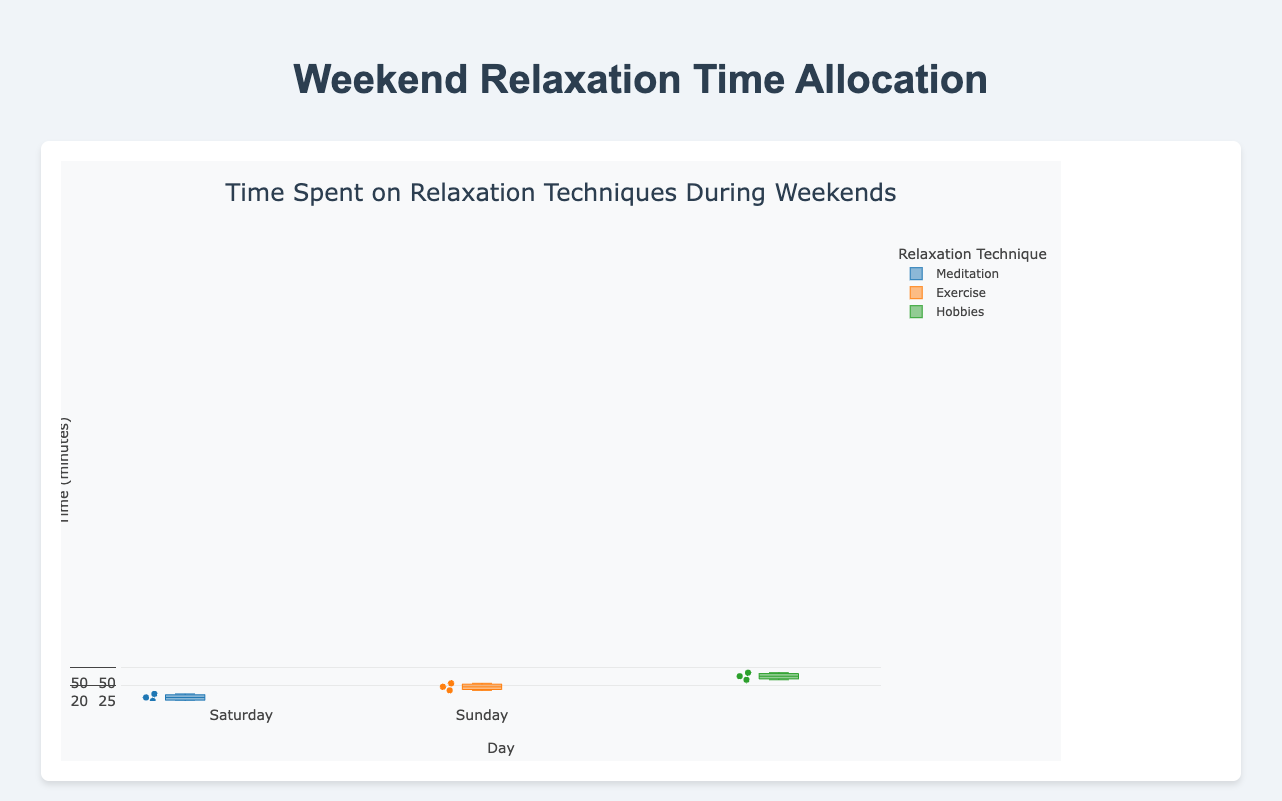What are the relaxation techniques shown in the plot? The plot displays data for three relaxation techniques: Meditation, Exercise, and Hobbies. You can identify the techniques by looking at the labeled box plots.
Answer: Meditation, Exercise, Hobbies Which day do people spend the most time on Hobbies? Observing the box plots for Hobbies, people spend the most time on Sunday because the median and the upper whisker are higher on Sunday compared to Saturday.
Answer: Sunday What is the median time spent on Meditation on Saturday? The median time is the line inside the box of the box plot for Meditation on Saturday. Observing this, the median is 20 minutes.
Answer: 20 minutes Which relaxation technique has the smallest range of time spent on Sunday? To determine this, compare the range (difference between the upper and lower whisker) of each technique on Sunday. Meditation has the smallest range as its whiskers extend from 20 to 35 minutes.
Answer: Meditation What is the interquartile range (IQR) for Exercise on Saturday? The interquartile range (IQR) is the difference between the upper quartile (75th percentile) and the lower quartile (25th percentile). For Exercise on Saturday, the lower quartile is at 45 minutes and the upper quartile is at 60 minutes, so IQR is 60 - 45 = 15 minutes.
Answer: 15 minutes Which day shows a higher variance in time spent on Meditation? Variance is indicated by the spread of data points. Comparing the box plots for Meditation on both days, Sunday shows a higher variance as the whiskers are more spread out.
Answer: Sunday What is the minimum time spent on Exercise on Sunday? The minimum time spent is the lowest point of the lower whisker on the box plot for Exercise on Sunday. This value is at 40 minutes.
Answer: 40 minutes Which relaxation technique has the highest median time spent across both days? By comparing the median lines within the box plots of each technique, Hobbies shows the highest median time spent across both days.
Answer: Hobbies What is the most time spent on a single session of Hobbies on Saturday? The maximum for Hobbies on Saturday can be observed from the upper whisker of the box plot, which is at 120 minutes.
Answer: 120 minutes 